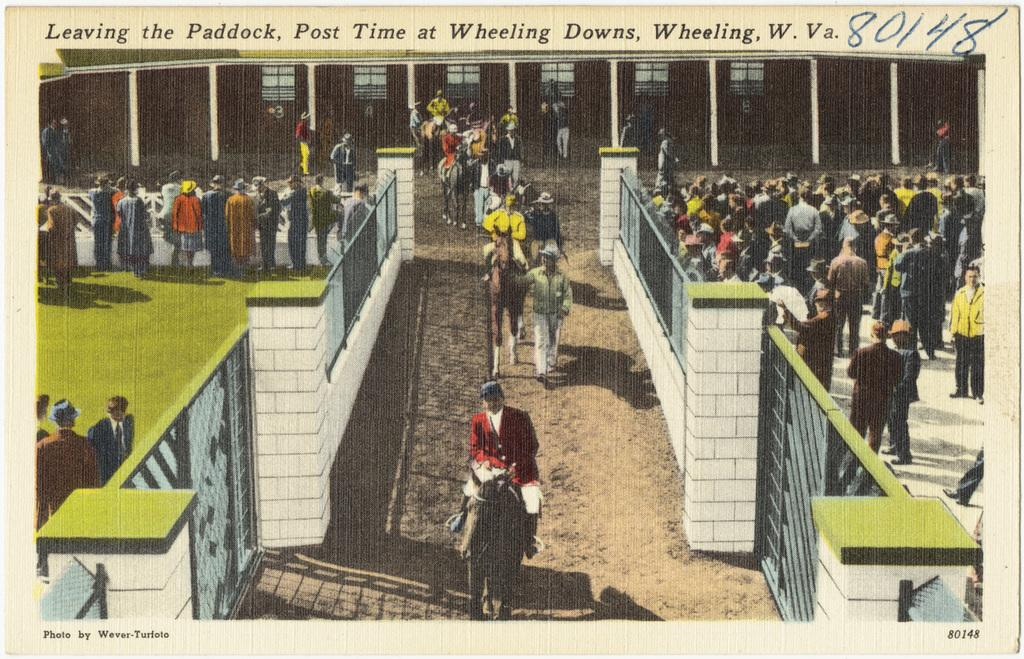Provide a one-sentence caption for the provided image. Competition is going to start soon and the horses are leaving the paddock. 